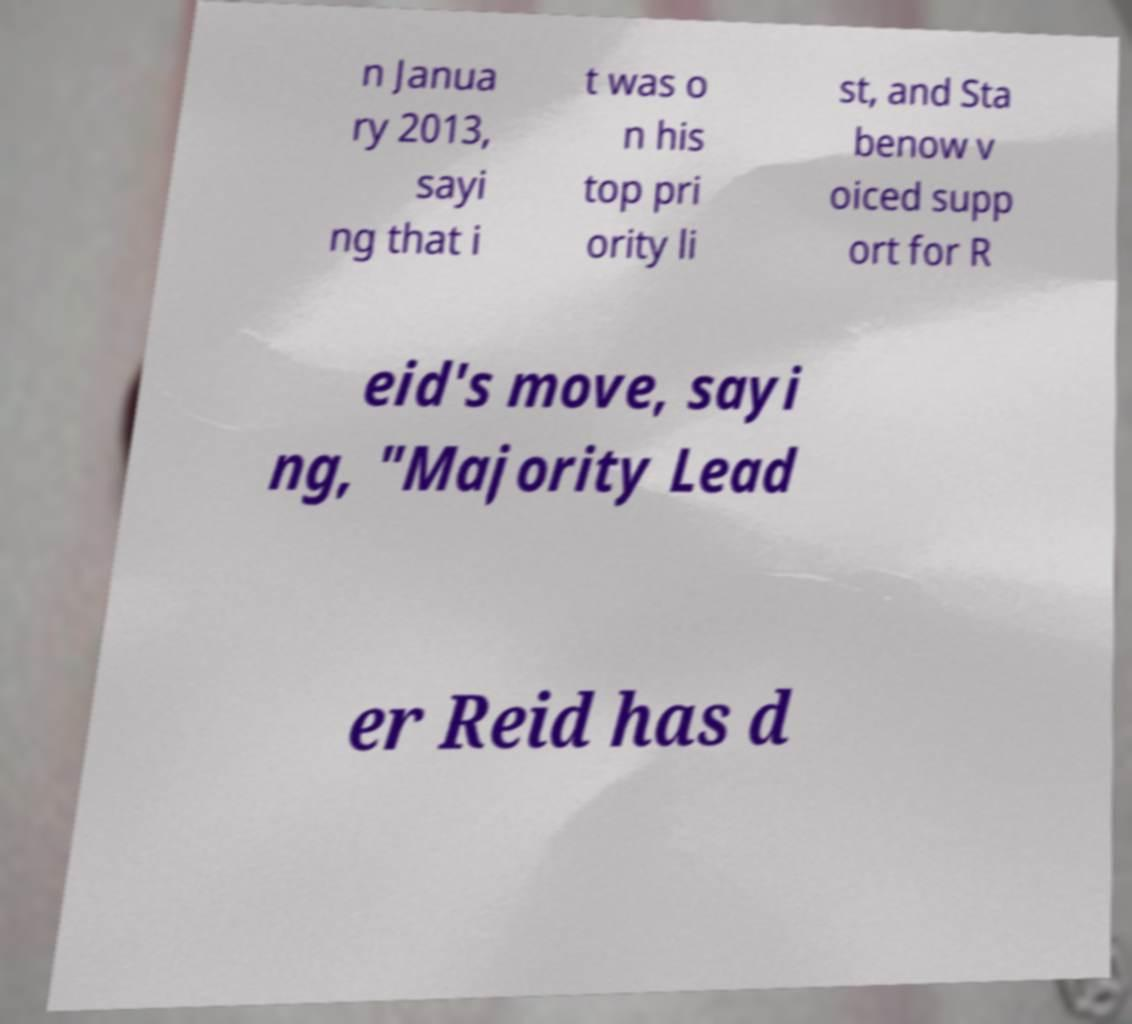Can you read and provide the text displayed in the image?This photo seems to have some interesting text. Can you extract and type it out for me? n Janua ry 2013, sayi ng that i t was o n his top pri ority li st, and Sta benow v oiced supp ort for R eid's move, sayi ng, "Majority Lead er Reid has d 